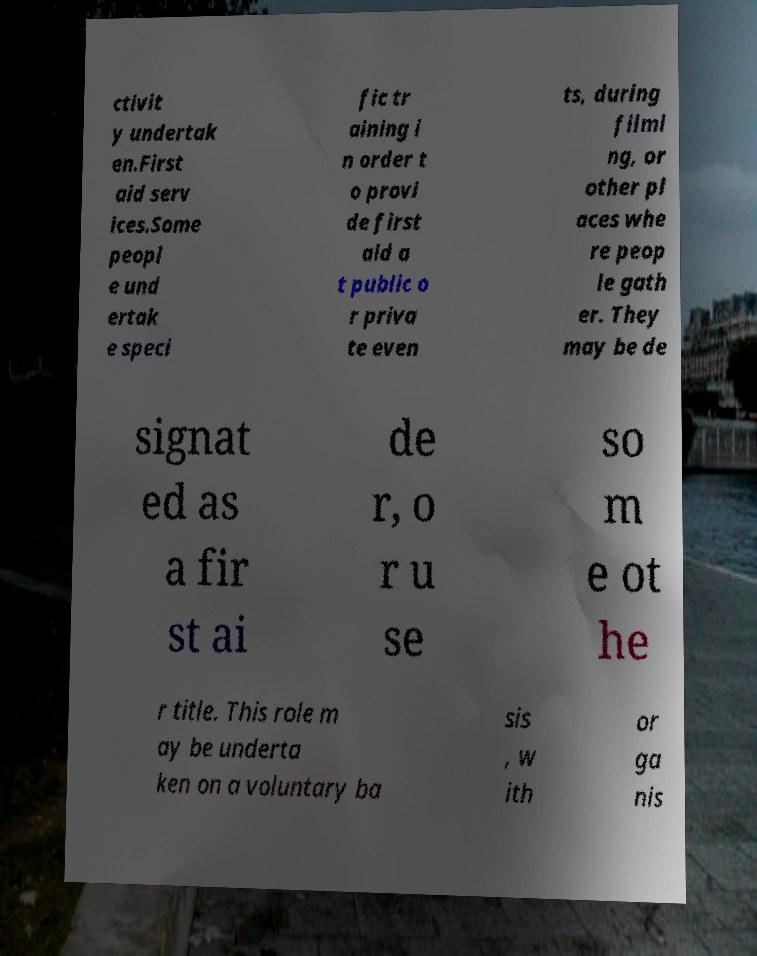Please identify and transcribe the text found in this image. ctivit y undertak en.First aid serv ices.Some peopl e und ertak e speci fic tr aining i n order t o provi de first aid a t public o r priva te even ts, during filmi ng, or other pl aces whe re peop le gath er. They may be de signat ed as a fir st ai de r, o r u se so m e ot he r title. This role m ay be underta ken on a voluntary ba sis , w ith or ga nis 